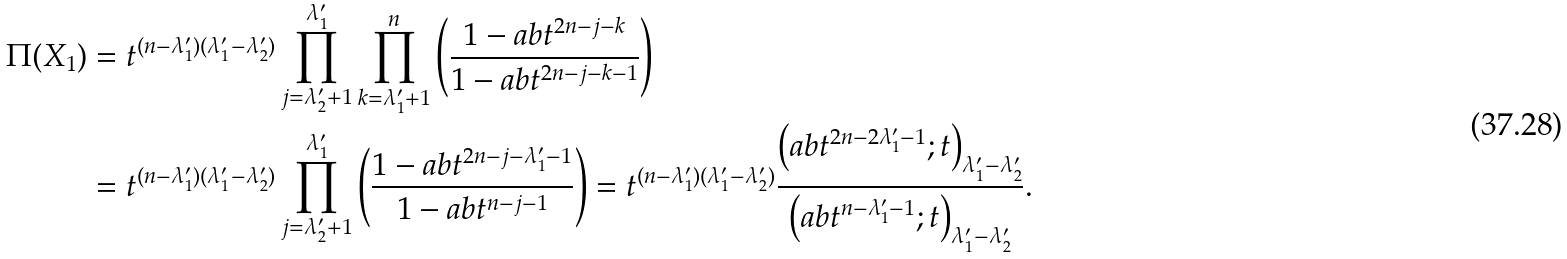<formula> <loc_0><loc_0><loc_500><loc_500>\Pi ( X _ { 1 } ) & = t ^ { ( n - \lambda _ { 1 } ^ { \prime } ) ( \lambda _ { 1 } ^ { \prime } - \lambda _ { 2 } ^ { \prime } ) } \prod _ { j = \lambda _ { 2 } ^ { \prime } + 1 } ^ { \lambda _ { 1 } ^ { \prime } } \prod _ { k = \lambda _ { 1 } ^ { \prime } + 1 } ^ { n } \left ( \frac { 1 - a b t ^ { 2 n - j - k } } { 1 - a b t ^ { 2 n - j - k - 1 } } \right ) \\ & = t ^ { ( n - \lambda _ { 1 } ^ { \prime } ) ( \lambda _ { 1 } ^ { \prime } - \lambda _ { 2 } ^ { \prime } ) } \prod _ { j = \lambda _ { 2 } ^ { \prime } + 1 } ^ { \lambda _ { 1 } ^ { \prime } } \left ( \frac { 1 - a b t ^ { 2 n - j - \lambda _ { 1 } ^ { \prime } - 1 } } { 1 - a b t ^ { n - j - 1 } } \right ) = t ^ { ( n - \lambda _ { 1 } ^ { \prime } ) ( \lambda _ { 1 } ^ { \prime } - \lambda _ { 2 } ^ { \prime } ) } \frac { \left ( a b t ^ { 2 n - 2 \lambda _ { 1 } ^ { \prime } - 1 } ; t \right ) _ { \lambda _ { 1 } ^ { \prime } - \lambda _ { 2 } ^ { \prime } } } { \left ( a b t ^ { n - \lambda _ { 1 } ^ { \prime } - 1 } ; t \right ) _ { \lambda _ { 1 } ^ { \prime } - \lambda _ { 2 } ^ { \prime } } } .</formula> 